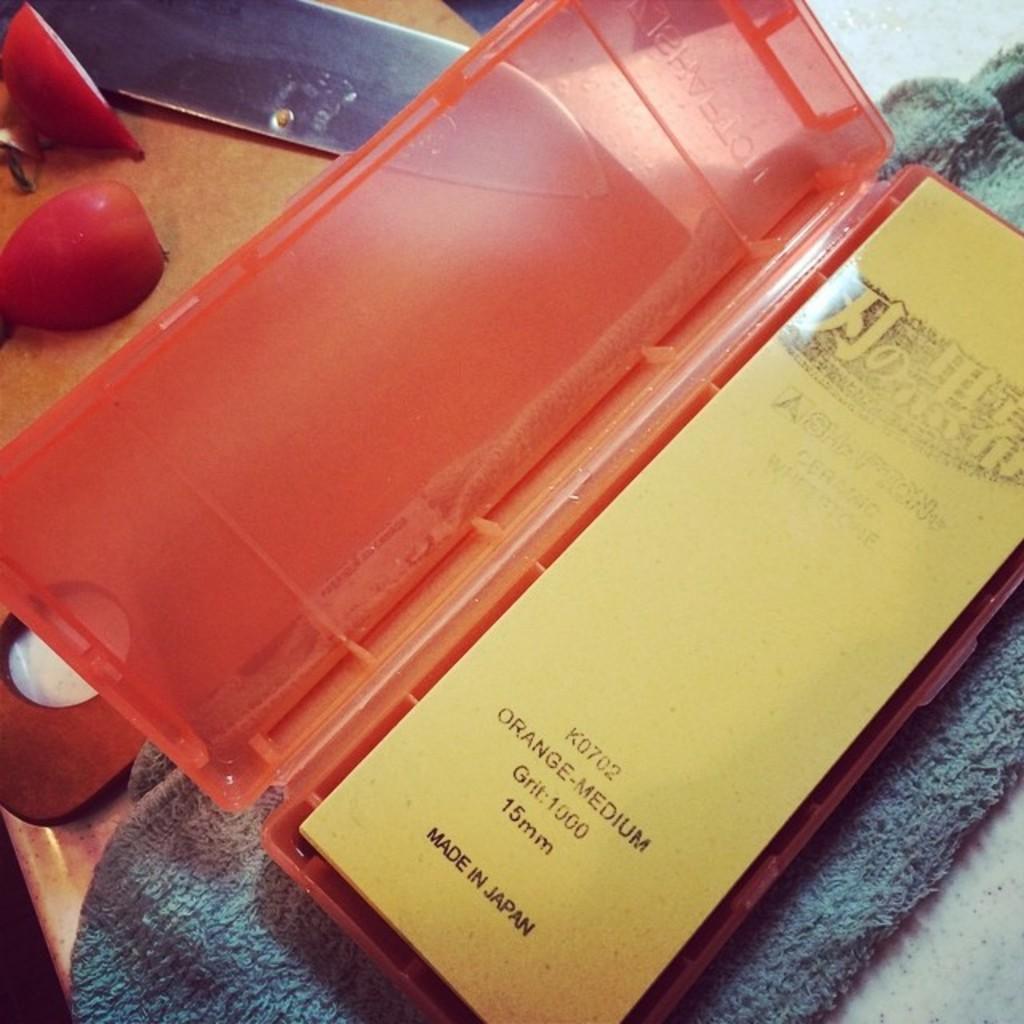What type of object can be seen in the image that is typically used for cutting? There is a knife in the image. What object in the image is often used for storage? There is a box in the image. What type of material is present in the image that can be used for cleaning or covering? There is a cloth in the image. Can you describe the platform in the image? There are a few other objects on the platform in the image. Where is the van parked in the image? There is no van present in the image. What color is the tongue of the person in the image? There is no person or tongue present in the image. 